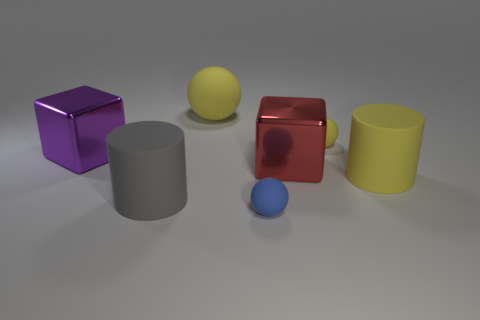Add 1 large yellow matte cylinders. How many objects exist? 8 Subtract all cubes. How many objects are left? 5 Add 3 small yellow spheres. How many small yellow spheres are left? 4 Add 4 tiny gray matte cubes. How many tiny gray matte cubes exist? 4 Subtract 0 cyan spheres. How many objects are left? 7 Subtract all large purple things. Subtract all yellow cylinders. How many objects are left? 5 